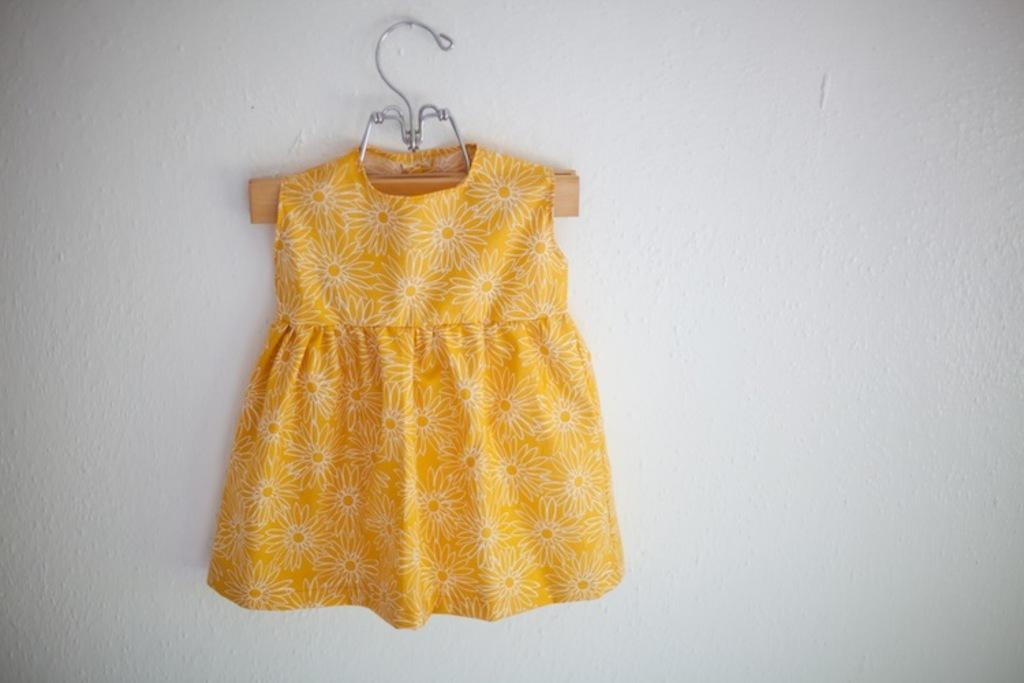What type of clothing item is in the image? There is a frock in the image. What is the frock hanging on? There is a hanger in the image. What can be seen behind the frock and hanger? There is a wall in the image. How many fish are swimming near the frock in the image? There are no fish present in the image. 